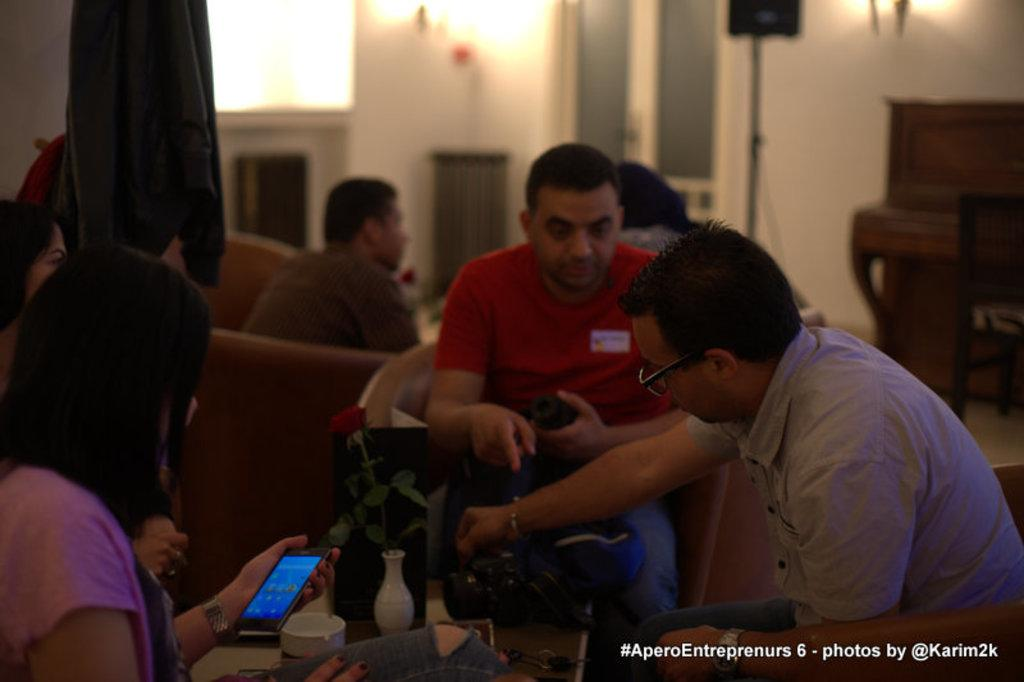Who or what can be seen in the image? There are people in the image. What are the people doing in the image? The people are sitting on chairs. What type of pest can be seen crawling on the people in the image? There are no pests visible in the image; the people are sitting on chairs. 